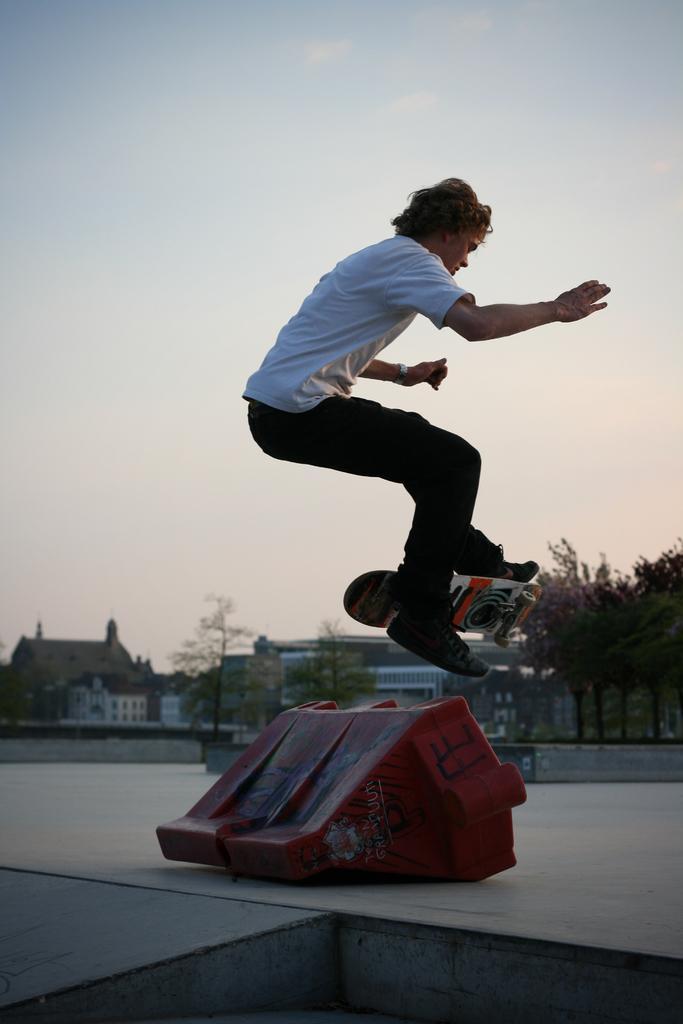Can you describe this image briefly? In this image I can see a person wearing white t shirt, black pant and black shoe is jumping in the air and I can see a skateboard below him. In the background I can see a red colored object on the ground, few buildings, few trees and the sky. 